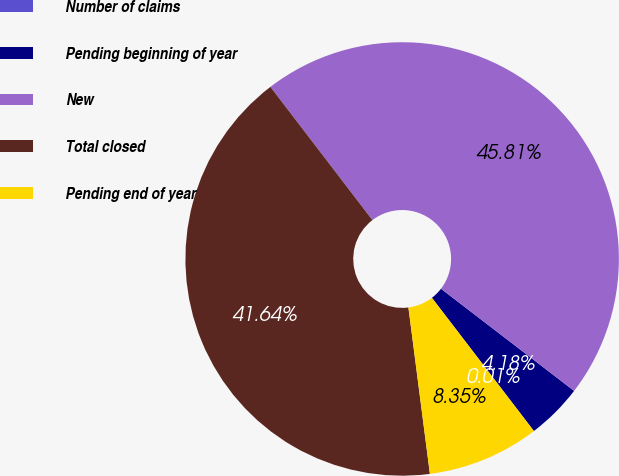Convert chart. <chart><loc_0><loc_0><loc_500><loc_500><pie_chart><fcel>Number of claims<fcel>Pending beginning of year<fcel>New<fcel>Total closed<fcel>Pending end of year<nl><fcel>0.01%<fcel>4.18%<fcel>45.81%<fcel>41.64%<fcel>8.35%<nl></chart> 